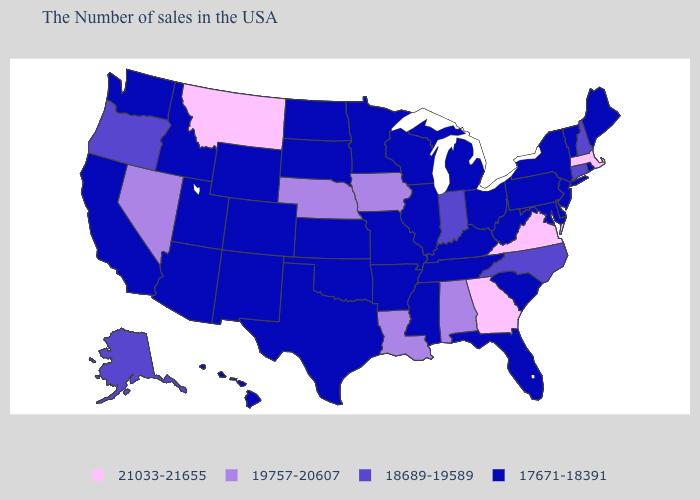How many symbols are there in the legend?
Keep it brief. 4. Does the first symbol in the legend represent the smallest category?
Answer briefly. No. Name the states that have a value in the range 18689-19589?
Give a very brief answer. New Hampshire, Connecticut, North Carolina, Indiana, Oregon, Alaska. What is the value of Colorado?
Write a very short answer. 17671-18391. Name the states that have a value in the range 21033-21655?
Concise answer only. Massachusetts, Virginia, Georgia, Montana. Does the first symbol in the legend represent the smallest category?
Give a very brief answer. No. Does Tennessee have the highest value in the USA?
Write a very short answer. No. What is the lowest value in states that border South Dakota?
Answer briefly. 17671-18391. Name the states that have a value in the range 17671-18391?
Be succinct. Maine, Rhode Island, Vermont, New York, New Jersey, Delaware, Maryland, Pennsylvania, South Carolina, West Virginia, Ohio, Florida, Michigan, Kentucky, Tennessee, Wisconsin, Illinois, Mississippi, Missouri, Arkansas, Minnesota, Kansas, Oklahoma, Texas, South Dakota, North Dakota, Wyoming, Colorado, New Mexico, Utah, Arizona, Idaho, California, Washington, Hawaii. What is the value of Missouri?
Keep it brief. 17671-18391. What is the lowest value in states that border Oklahoma?
Short answer required. 17671-18391. Which states hav the highest value in the MidWest?
Write a very short answer. Iowa, Nebraska. Name the states that have a value in the range 18689-19589?
Be succinct. New Hampshire, Connecticut, North Carolina, Indiana, Oregon, Alaska. Does New Mexico have a lower value than Louisiana?
Give a very brief answer. Yes. What is the value of Wyoming?
Write a very short answer. 17671-18391. 